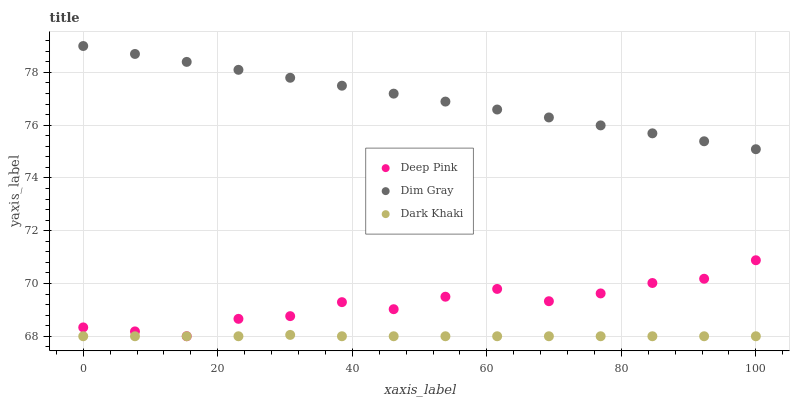Does Dark Khaki have the minimum area under the curve?
Answer yes or no. Yes. Does Dim Gray have the maximum area under the curve?
Answer yes or no. Yes. Does Deep Pink have the minimum area under the curve?
Answer yes or no. No. Does Deep Pink have the maximum area under the curve?
Answer yes or no. No. Is Dim Gray the smoothest?
Answer yes or no. Yes. Is Deep Pink the roughest?
Answer yes or no. Yes. Is Deep Pink the smoothest?
Answer yes or no. No. Is Dim Gray the roughest?
Answer yes or no. No. Does Dark Khaki have the lowest value?
Answer yes or no. Yes. Does Dim Gray have the lowest value?
Answer yes or no. No. Does Dim Gray have the highest value?
Answer yes or no. Yes. Does Deep Pink have the highest value?
Answer yes or no. No. Is Dark Khaki less than Dim Gray?
Answer yes or no. Yes. Is Dim Gray greater than Dark Khaki?
Answer yes or no. Yes. Does Dark Khaki intersect Deep Pink?
Answer yes or no. Yes. Is Dark Khaki less than Deep Pink?
Answer yes or no. No. Is Dark Khaki greater than Deep Pink?
Answer yes or no. No. Does Dark Khaki intersect Dim Gray?
Answer yes or no. No. 